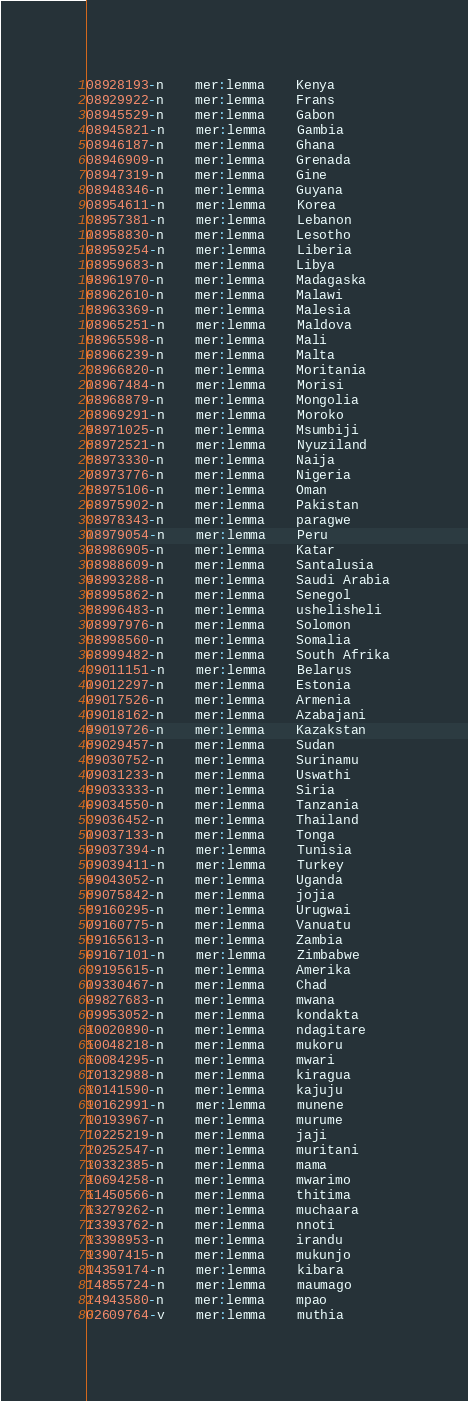Convert code to text. <code><loc_0><loc_0><loc_500><loc_500><_SQL_>08928193-n	mer:lemma	Kenya
08929922-n	mer:lemma	Frans
08945529-n	mer:lemma	Gabon
08945821-n	mer:lemma	Gambia
08946187-n	mer:lemma	Ghana
08946909-n	mer:lemma	Grenada
08947319-n	mer:lemma	Gine
08948346-n	mer:lemma	Guyana
08954611-n	mer:lemma	Korea
08957381-n	mer:lemma	Lebanon
08958830-n	mer:lemma	Lesotho
08959254-n	mer:lemma	Liberia
08959683-n	mer:lemma	Libya
08961970-n	mer:lemma	Madagaska
08962610-n	mer:lemma	Malawi
08963369-n	mer:lemma	Malesia
08965251-n	mer:lemma	Maldova
08965598-n	mer:lemma	Mali
08966239-n	mer:lemma	Malta
08966820-n	mer:lemma	Moritania
08967484-n	mer:lemma	Morisi
08968879-n	mer:lemma	Mongolia
08969291-n	mer:lemma	Moroko
08971025-n	mer:lemma	Msumbiji
08972521-n	mer:lemma	Nyuziland
08973330-n	mer:lemma	Naija
08973776-n	mer:lemma	Nigeria
08975106-n	mer:lemma	Oman
08975902-n	mer:lemma	Pakistan
08978343-n	mer:lemma	paragwe
08979054-n	mer:lemma	Peru
08986905-n	mer:lemma	Katar
08988609-n	mer:lemma	Santalusia
08993288-n	mer:lemma	Saudi Arabia
08995862-n	mer:lemma	Senegol
08996483-n	mer:lemma	ushelisheli
08997976-n	mer:lemma	Solomon
08998560-n	mer:lemma	Somalia
08999482-n	mer:lemma	South Afrika
09011151-n	mer:lemma	Belarus
09012297-n	mer:lemma	Estonia
09017526-n	mer:lemma	Armenia
09018162-n	mer:lemma	Azabajani
09019726-n	mer:lemma	Kazakstan
09029457-n	mer:lemma	Sudan
09030752-n	mer:lemma	Surinamu
09031233-n	mer:lemma	Uswathi
09033333-n	mer:lemma	Siria
09034550-n	mer:lemma	Tanzania
09036452-n	mer:lemma	Thailand
09037133-n	mer:lemma	Tonga
09037394-n	mer:lemma	Tunisia
09039411-n	mer:lemma	Turkey
09043052-n	mer:lemma	Uganda
09075842-n	mer:lemma	jojia
09160295-n	mer:lemma	Urugwai
09160775-n	mer:lemma	Vanuatu
09165613-n	mer:lemma	Zambia
09167101-n	mer:lemma	Zimbabwe
09195615-n	mer:lemma	Amerika
09330467-n	mer:lemma	Chad
09827683-n	mer:lemma	mwana
09953052-n	mer:lemma	kondakta
10020890-n	mer:lemma	ndagitare
10048218-n	mer:lemma	mukoru
10084295-n	mer:lemma	mwari
10132988-n	mer:lemma	kiragua
10141590-n	mer:lemma	kajuju
10162991-n	mer:lemma	munene
10193967-n	mer:lemma	murume
10225219-n	mer:lemma	jaji
10252547-n	mer:lemma	muritani
10332385-n	mer:lemma	mama
10694258-n	mer:lemma	mwarimo
11450566-n	mer:lemma	thitima
13279262-n	mer:lemma	muchaara
13393762-n	mer:lemma	nnoti
13398953-n	mer:lemma	irandu
13907415-n	mer:lemma	mukunjo
14359174-n	mer:lemma	kibara
14855724-n	mer:lemma	maumago
14943580-n	mer:lemma	mpao
02609764-v	mer:lemma	muthia
</code> 